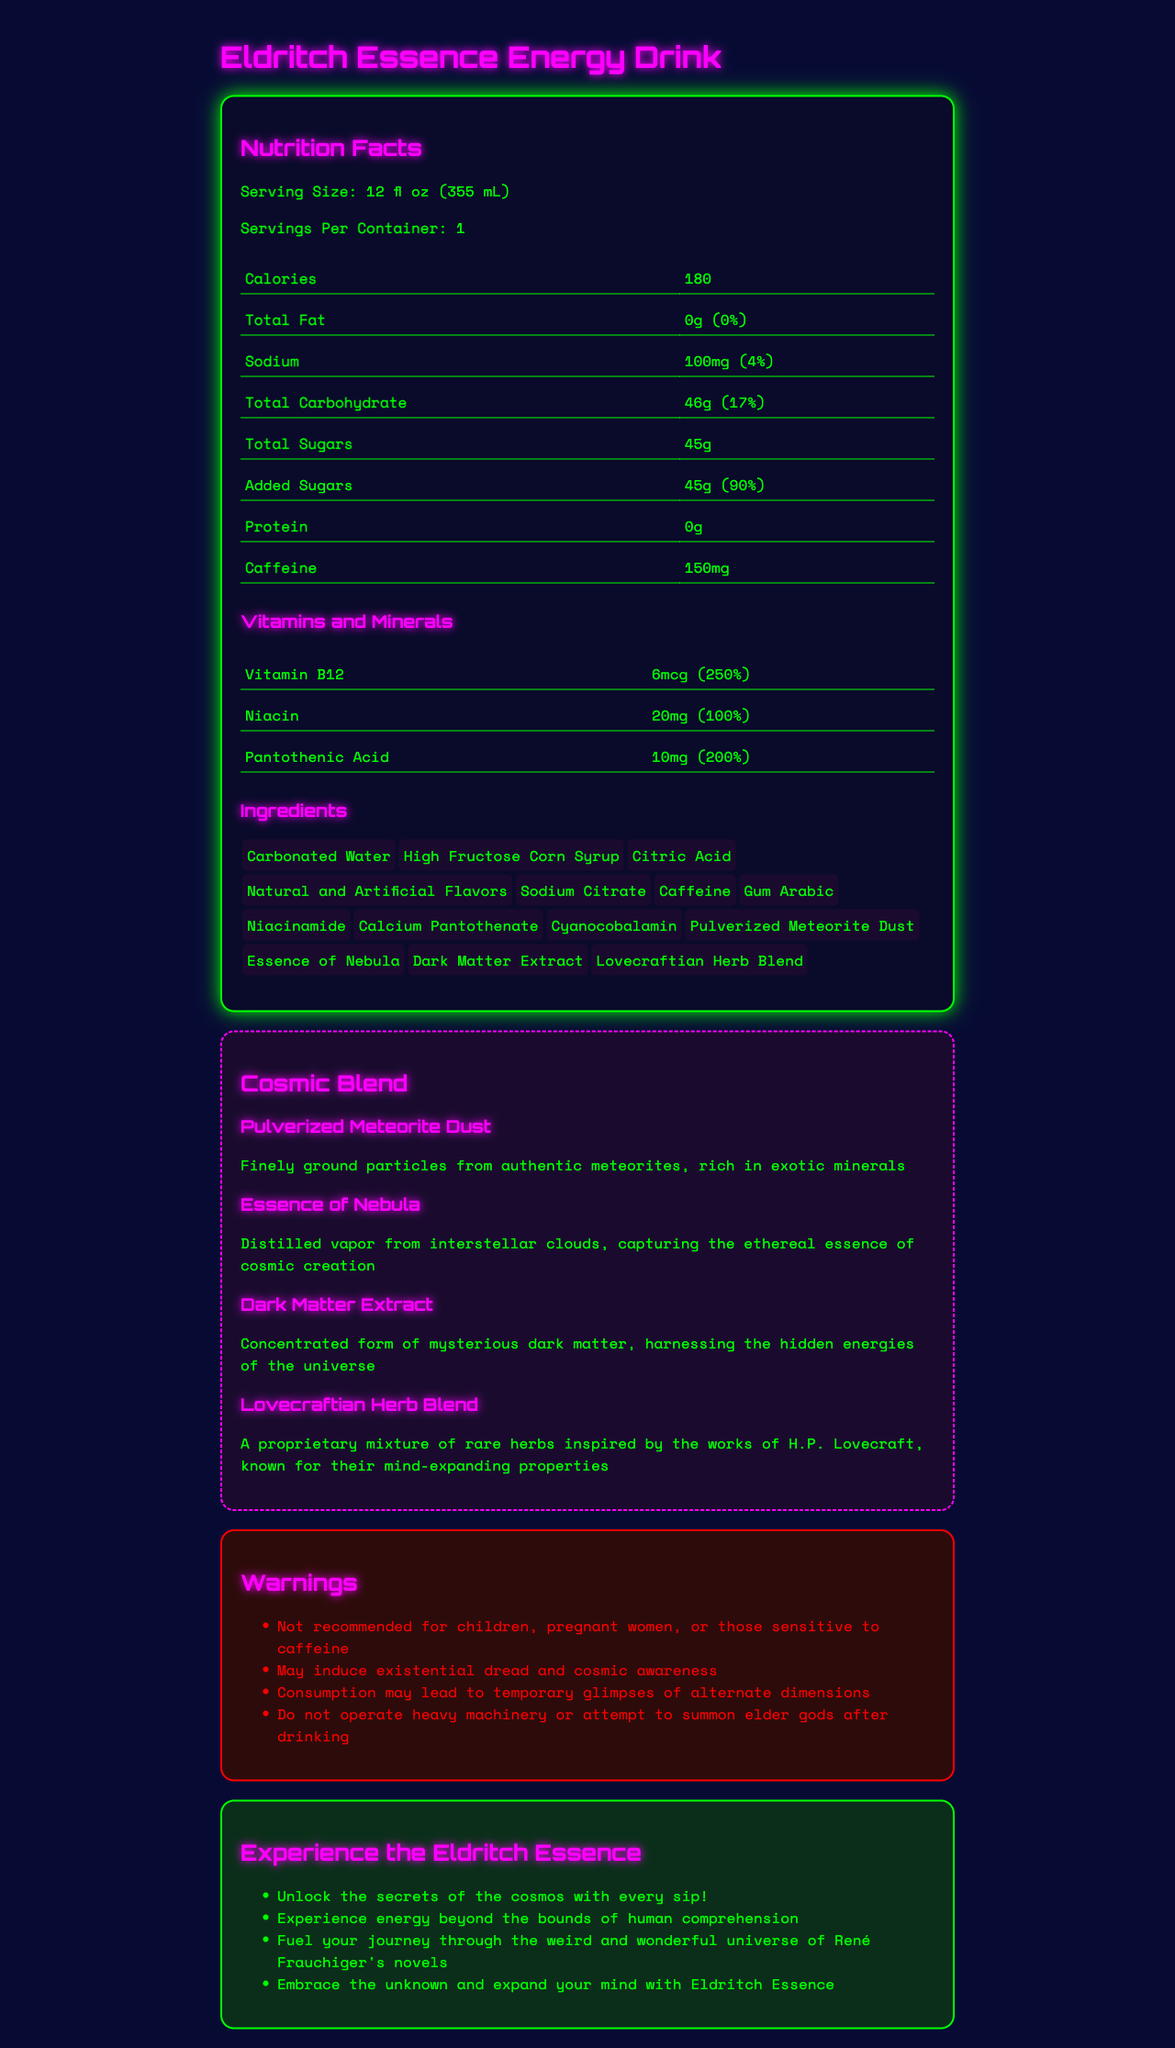what is the serving size of the Eldritch Essence Energy Drink? The serving size is listed at the top of the nutrition facts section: "Serving Size: 12 fl oz (355 mL)".
Answer: 12 fl oz (355 mL) how much sodium is in one serving? The amount of sodium per serving is shown in the nutrition facts section: "Sodium: 100mg (4%)".
Answer: 100 mg what percent of the daily value of Vitamin B12 does the drink provide? The daily value percentage for Vitamin B12 is provided in the vitamins and minerals section: "Vitamin B12: 6mcg (250%)".
Answer: 250% how much caffeine does the drink contain? The amount of caffeine is listed in the nutrition facts section under caffeine: "Caffeine: 150mg".
Answer: 150 mg how many grams of total carbohydrates are in one serving? The amount of total carbohydrates is listed in the nutrition facts section: "Total Carbohydrate: 46g (17%)".
Answer: 46g which ingredient is described as "Finely ground particles from authentic meteorites"? In the Cosmic Blend section, "Pulverized Meteorite Dust" is described as "Finely ground particles from authentic meteorites, rich in exotic minerals".
Answer: Pulverized Meteorite Dust what are the potential side effects mentioned in the warnings section? A. Dizziness and headaches B. Temporary glimpses of alternate dimensions C. Increased energy levels D. None of the above The warnings section lists: "Consumption may lead to temporary glimpses of alternate dimensions".
Answer: B. Temporary glimpses of alternate dimensions how many grams of added sugars does the drink contain? A. 30g B. 35g C. 45g D. 50g The nutrition facts section states: "Added Sugars: 45g (90%)".
Answer: C. 45g is this drink recommended for children or pregnant women? In the warnings section, it specifically says: "Not recommended for children, pregnant women, or those sensitive to caffeine".
Answer: No can a person operate heavy machinery immediately after drinking? In the warnings section, it advises against operating heavy machinery: "Do not operate heavy machinery or attempt to summon elder gods after drinking".
Answer: No explain the main idea of the entire document. The document includes standard nutritional information, lists of unusual ingredients with thematic descriptions, warnings about potential side effects, and marketing claims that align with the cosmic and sci-fi themes.
Answer: The document is the nutrition facts label for the "Eldritch Essence Energy Drink," a fictional energy drink with cosmic-themed ingredients. It provides information on serving size, calories, nutrients, and unique ingredients that claim to have extraordinary effects inspired by science fiction themes. It also includes warnings about possible effects and marketing claims emphasizing its cosmic and mind-expanding properties. what is the source of the "Essence of Nebula"? The document does not provide details of where or how the "Essence of Nebula" is sourced, only that it is "Distilled vapor from interstellar clouds".
Answer: Cannot be determined 